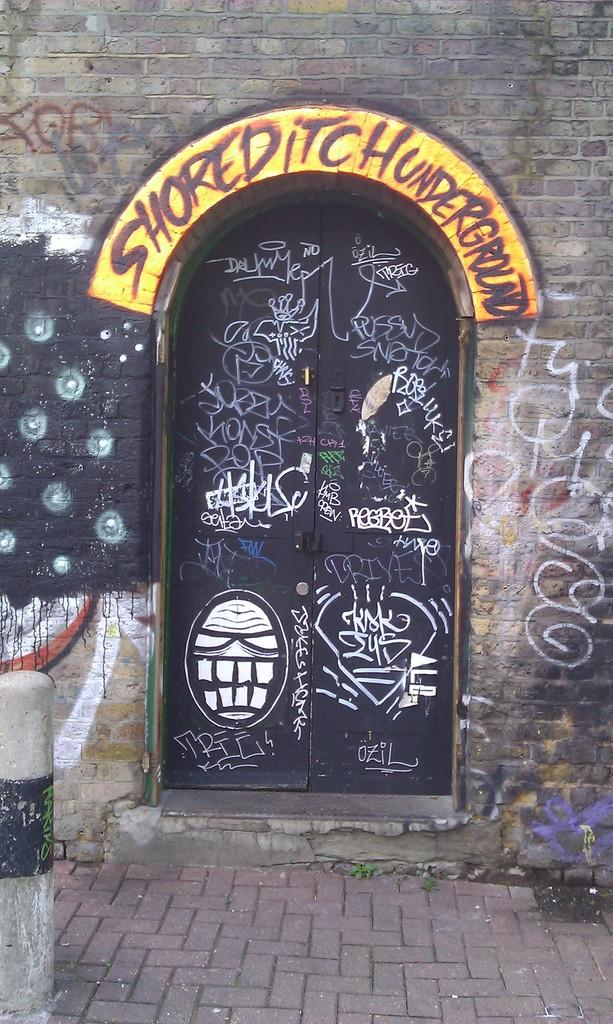What type of structure is visible in the image? There is a building in the image. What feature can be seen on the building? There are doors on the building. What is written or displayed on the doors? There is text and a drawing on the doors. What else can be seen in the image besides the building? There is a pole and a board with text in the image. What type of cookware is hanging from the pole in the image? There is no cookware present in the image; the pole is not associated with any cooking equipment. 